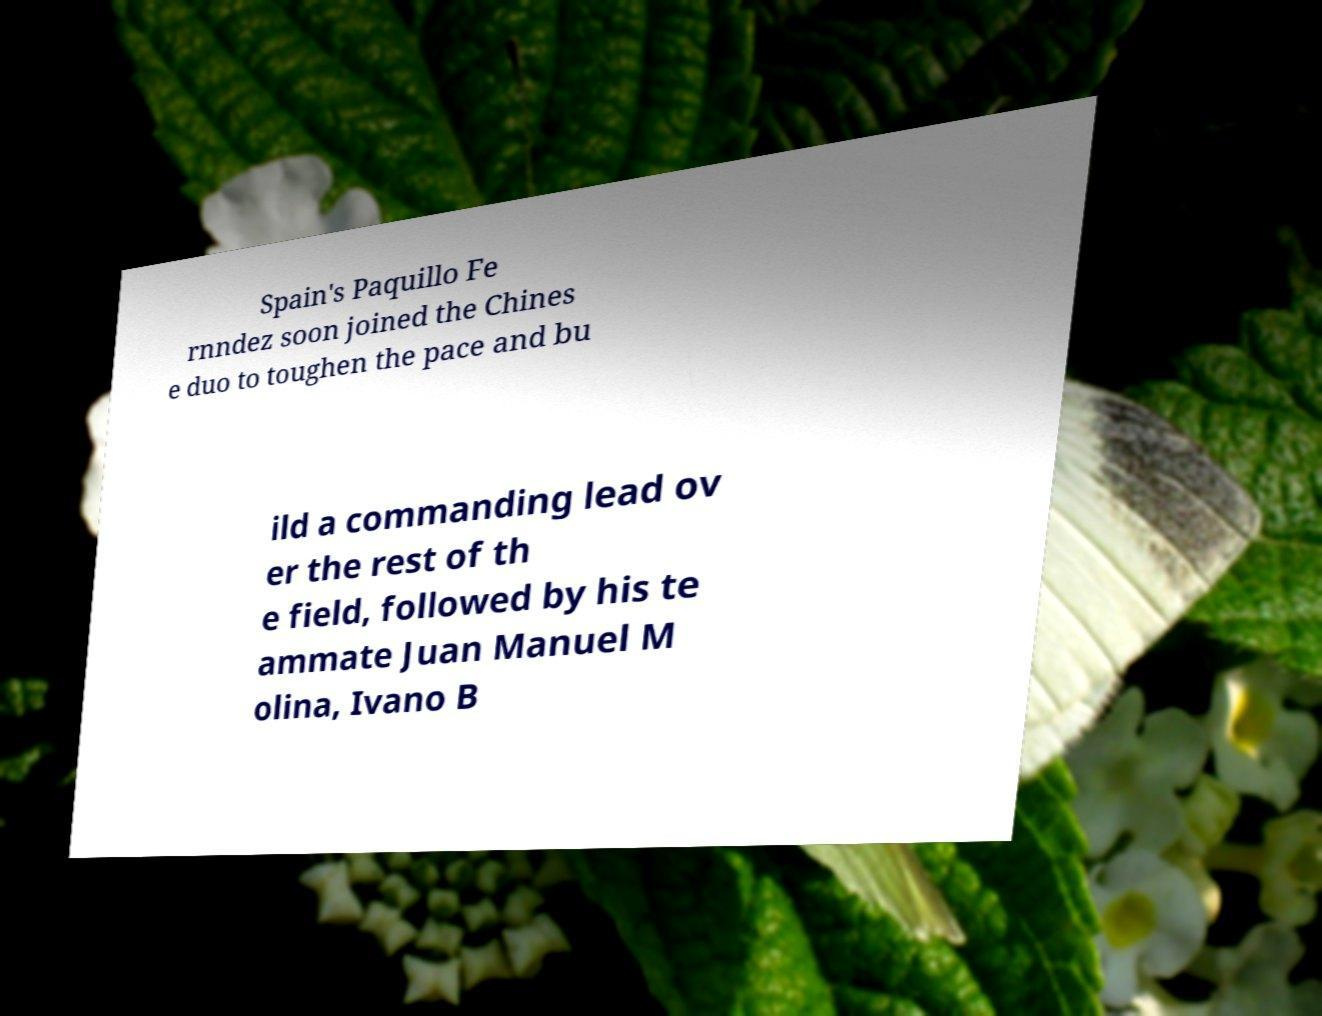Please identify and transcribe the text found in this image. Spain's Paquillo Fe rnndez soon joined the Chines e duo to toughen the pace and bu ild a commanding lead ov er the rest of th e field, followed by his te ammate Juan Manuel M olina, Ivano B 